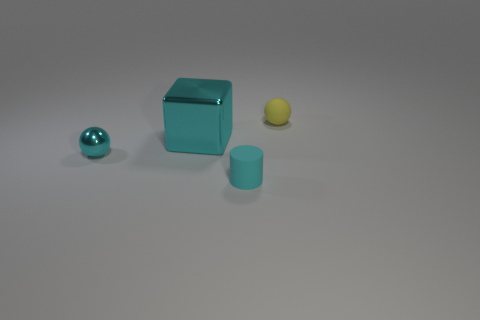Add 3 cyan metal blocks. How many objects exist? 7 Subtract all cylinders. How many objects are left? 3 Subtract 1 balls. How many balls are left? 1 Subtract all brown cylinders. Subtract all yellow spheres. How many cylinders are left? 1 Subtract all yellow cubes. How many cyan spheres are left? 1 Subtract all blocks. Subtract all small cyan rubber cylinders. How many objects are left? 2 Add 1 cyan blocks. How many cyan blocks are left? 2 Add 2 cyan things. How many cyan things exist? 5 Subtract 0 brown spheres. How many objects are left? 4 